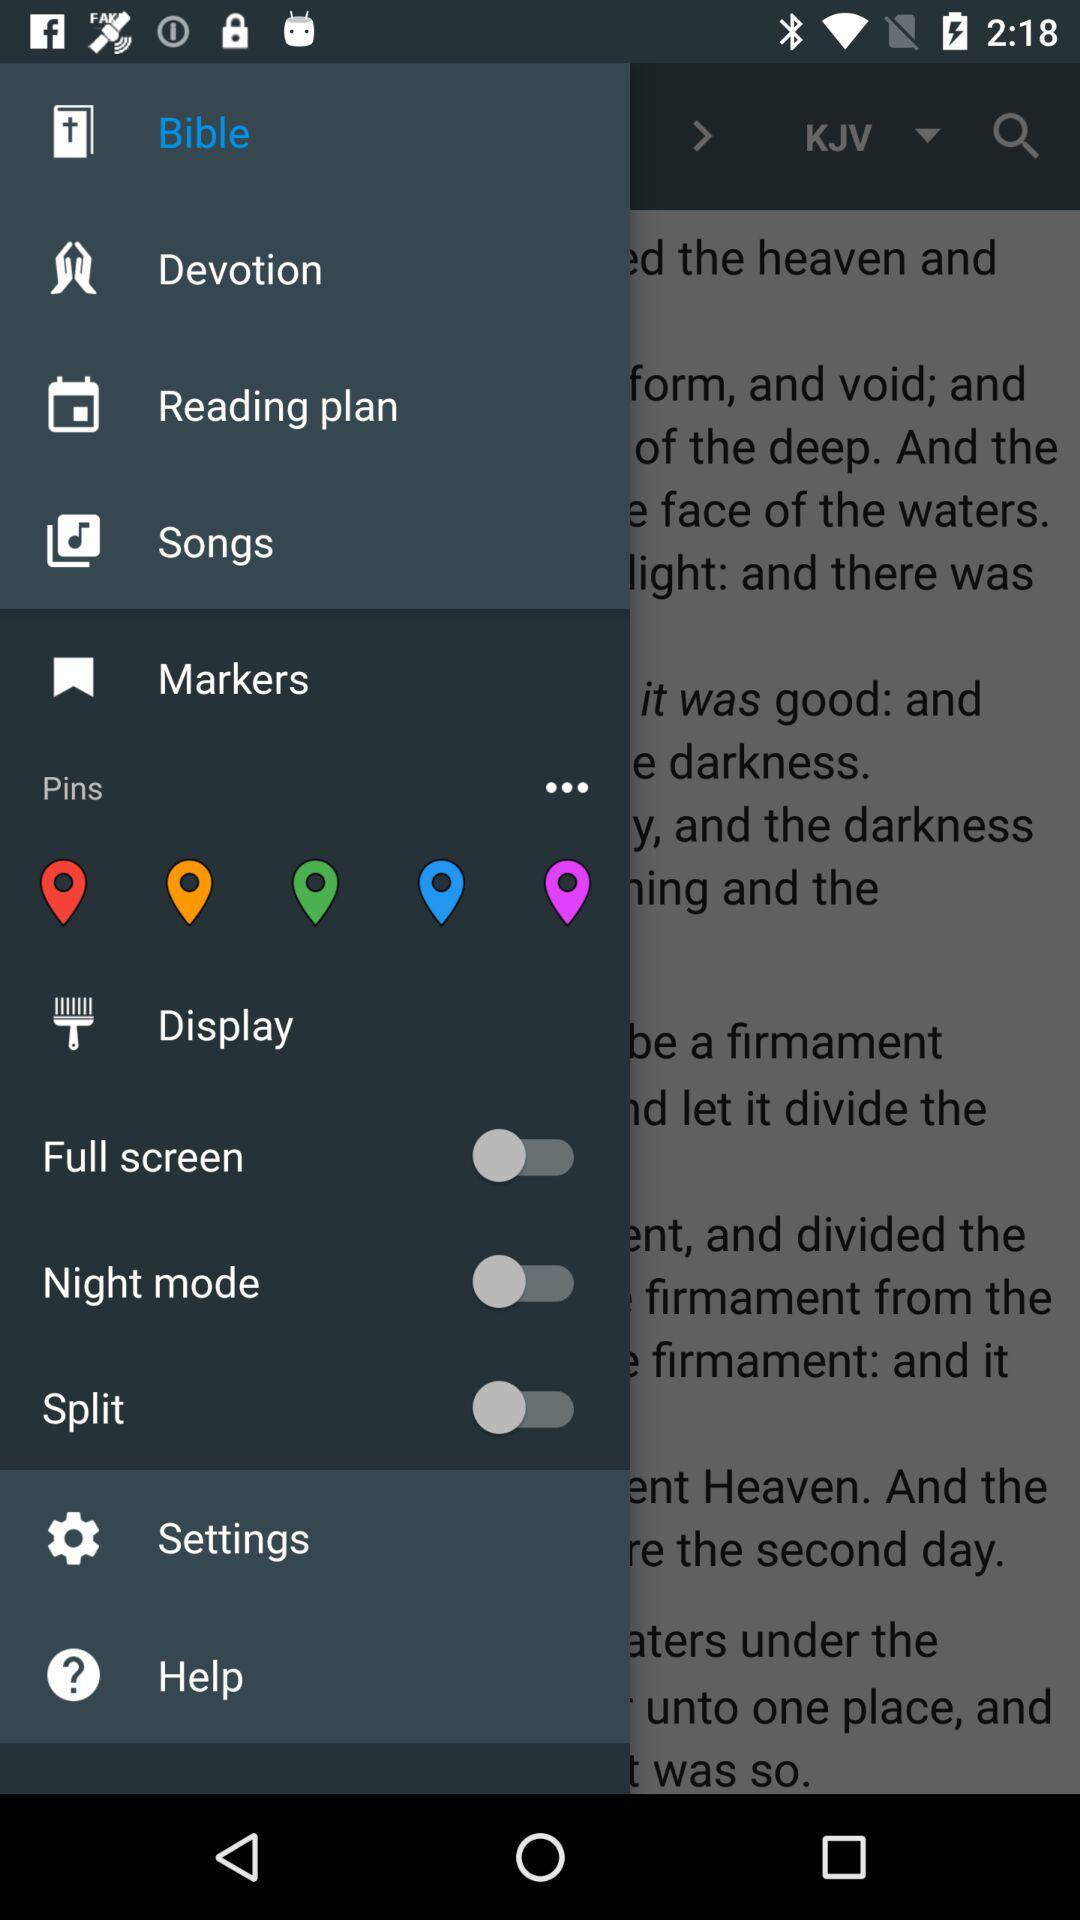What is the status of "Split"? The status of "Split" is "off". 